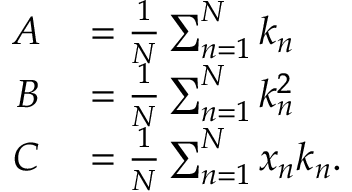<formula> <loc_0><loc_0><loc_500><loc_500>\begin{array} { r l } { A } & = \frac { 1 } { N } \sum _ { n = 1 } ^ { N } k _ { n } } \\ { B } & = \frac { 1 } { N } \sum _ { n = 1 } ^ { N } k _ { n } ^ { 2 } } \\ { C } & = \frac { 1 } { N } \sum _ { n = 1 } ^ { N } x _ { n } k _ { n } . } \end{array}</formula> 